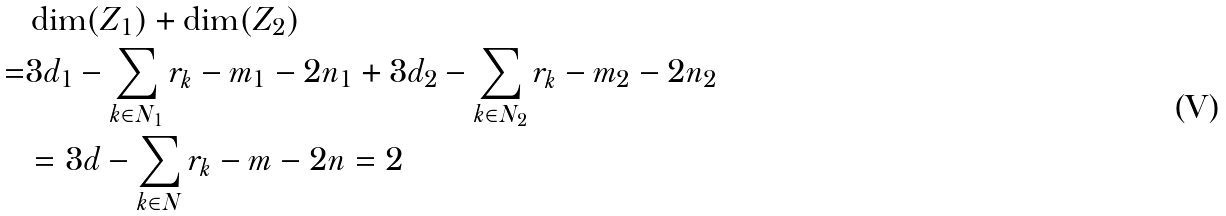Convert formula to latex. <formula><loc_0><loc_0><loc_500><loc_500>& \dim ( Z _ { 1 } ) + \dim ( Z _ { 2 } ) \\ = & 3 d _ { 1 } - \sum _ { k \in N _ { 1 } } r _ { k } - m _ { 1 } - 2 n _ { 1 } + 3 d _ { 2 } - \sum _ { k \in N _ { 2 } } r _ { k } - m _ { 2 } - 2 n _ { 2 } \\ & = 3 d - \sum _ { k \in N } r _ { k } - m - 2 n = 2</formula> 